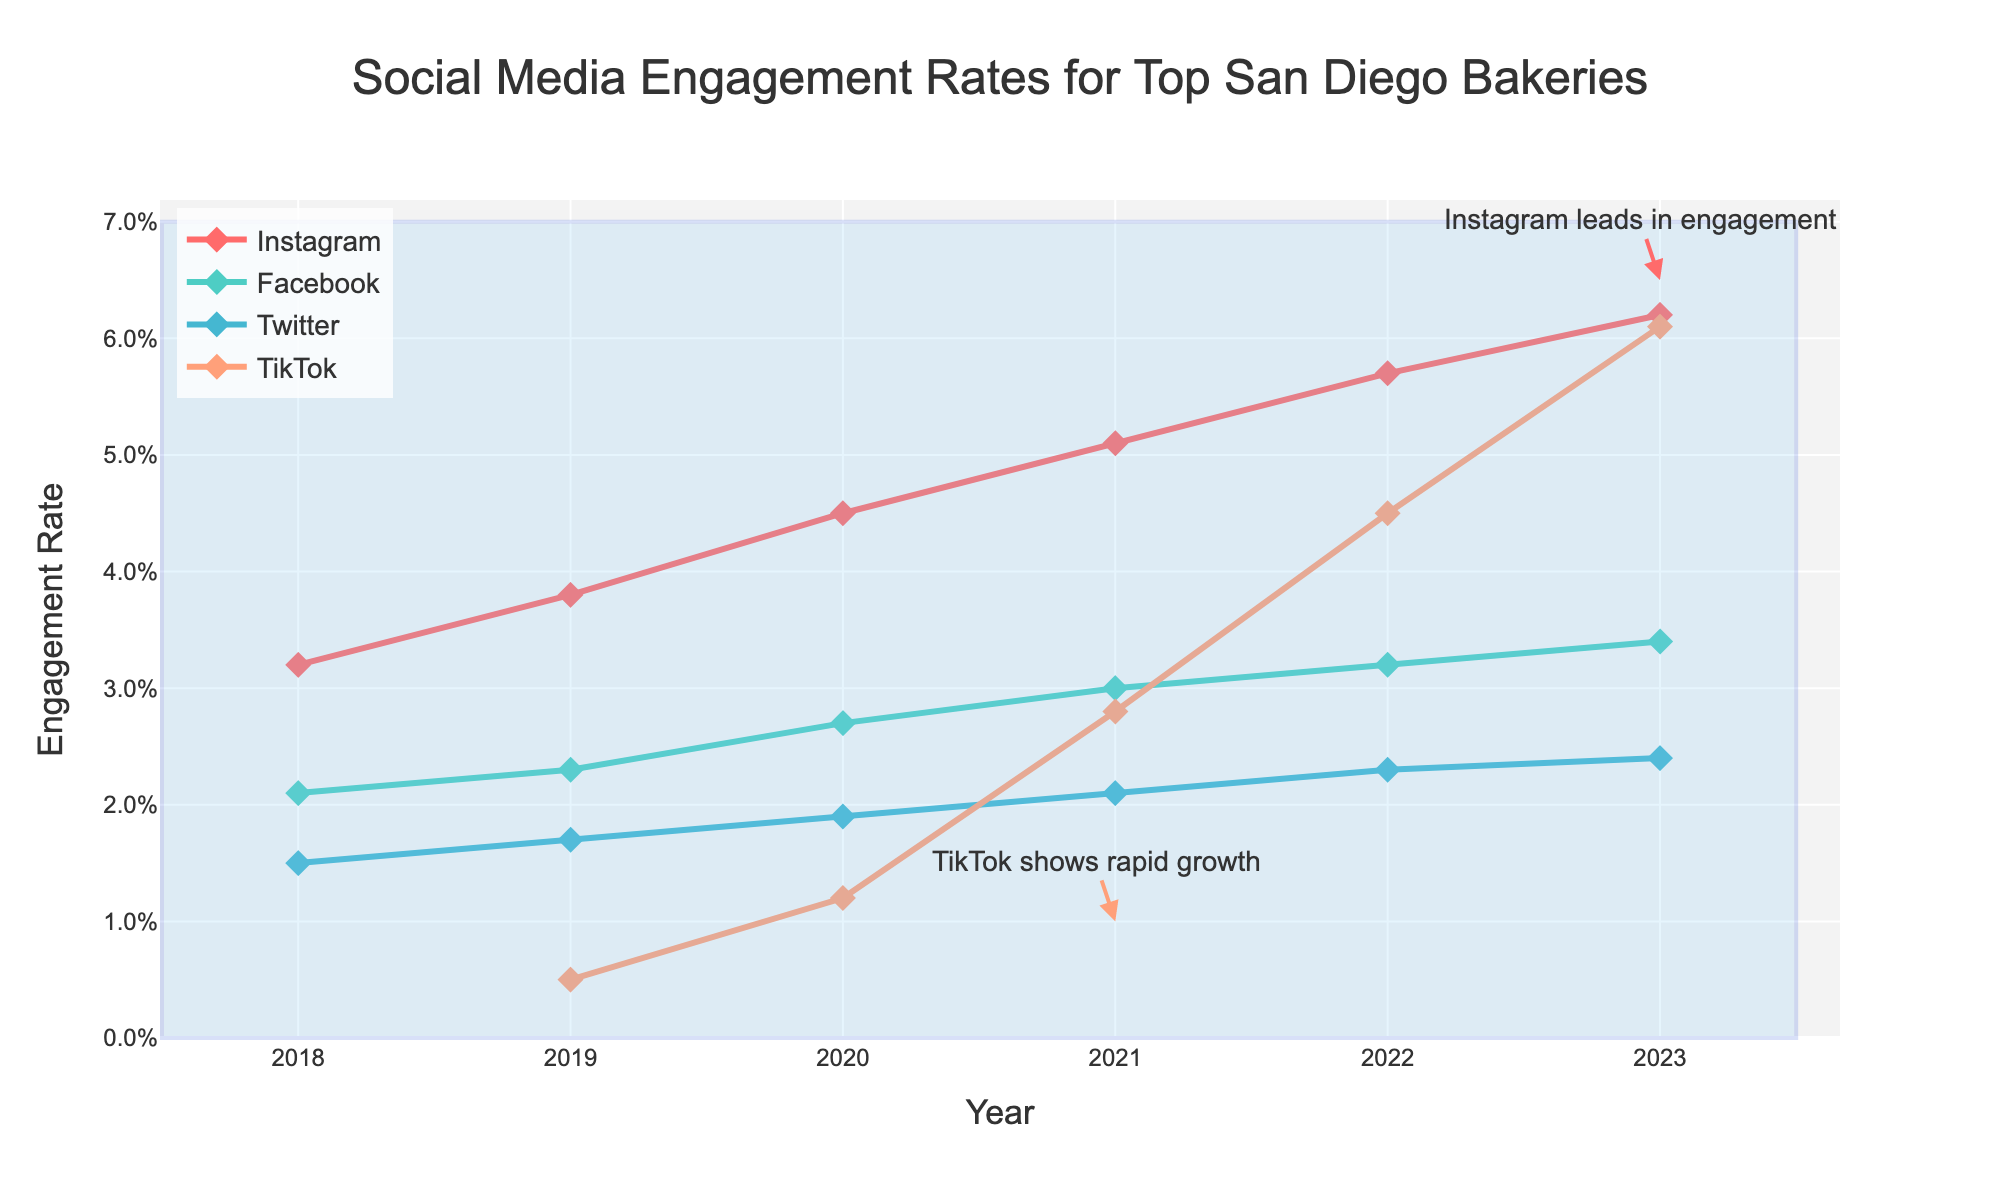What is the engagement rate trend for Instagram from 2018 to 2023? The line for Instagram shows an increasing trend over the years, starting at 3.2% in 2018 and reaching 6.2% in 2023.
Answer: Increasing Which social media platform had the highest engagement rate in 2023? By looking at the data points for 2023, Instagram has the highest engagement rate with 6.2%.
Answer: Instagram What was the difference in engagement rate between Instagram and Facebook in 2021? The engagement rate for Instagram in 2021 was 5.1%, and for Facebook, it was 3.0%. The difference is calculated as 5.1% - 3.0% = 2.1%.
Answer: 2.1% Which platform showed rapid growth between 2019 and 2023? The figure has an annotation pointing out that TikTok showed rapid growth. The TikTok line starts at 0.5% in 2019 and increases to 6.1% in 2023.
Answer: TikTok What is the average engagement rate across all platforms in 2020? Adding up the engagement rates for Instagram (4.5%), Facebook (2.7%), Twitter (1.9%), and TikTok (1.2%) gives a total of 10.3%. Dividing by 4, the average is 10.3% / 4 = 2.575%.
Answer: 2.575% Which social media platform experienced the least growth from 2018 to 2023? From the chart, the Twitter line shows the least growth. Its engagement rate went from 1.5% in 2018 to 2.4% in 2023.
Answer: Twitter Compare Facebook and Twitter engagement rates in the year 2022. Which one was higher? In 2022, Facebook had an engagement rate of 3.2%, while Twitter had an engagement rate of 2.3%. So, Facebook's engagement rate was higher.
Answer: Facebook How did the engagement rate for TikTok change between 2019 and 2021? TikTok's engagement rate increased from 0.5% in 2019 to 2.8% in 2021. So, the change is 2.8% - 0.5% = 2.3%.
Answer: 2.3% 